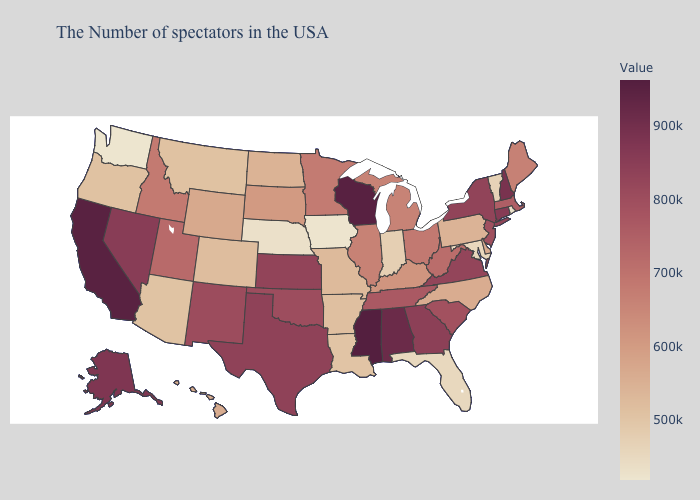Which states hav the highest value in the West?
Quick response, please. California. Does North Carolina have the highest value in the USA?
Write a very short answer. No. Does Mississippi have the highest value in the USA?
Concise answer only. Yes. Among the states that border Indiana , which have the lowest value?
Answer briefly. Kentucky. Does the map have missing data?
Short answer required. No. Among the states that border Nevada , which have the highest value?
Answer briefly. California. Which states have the highest value in the USA?
Be succinct. Mississippi. 